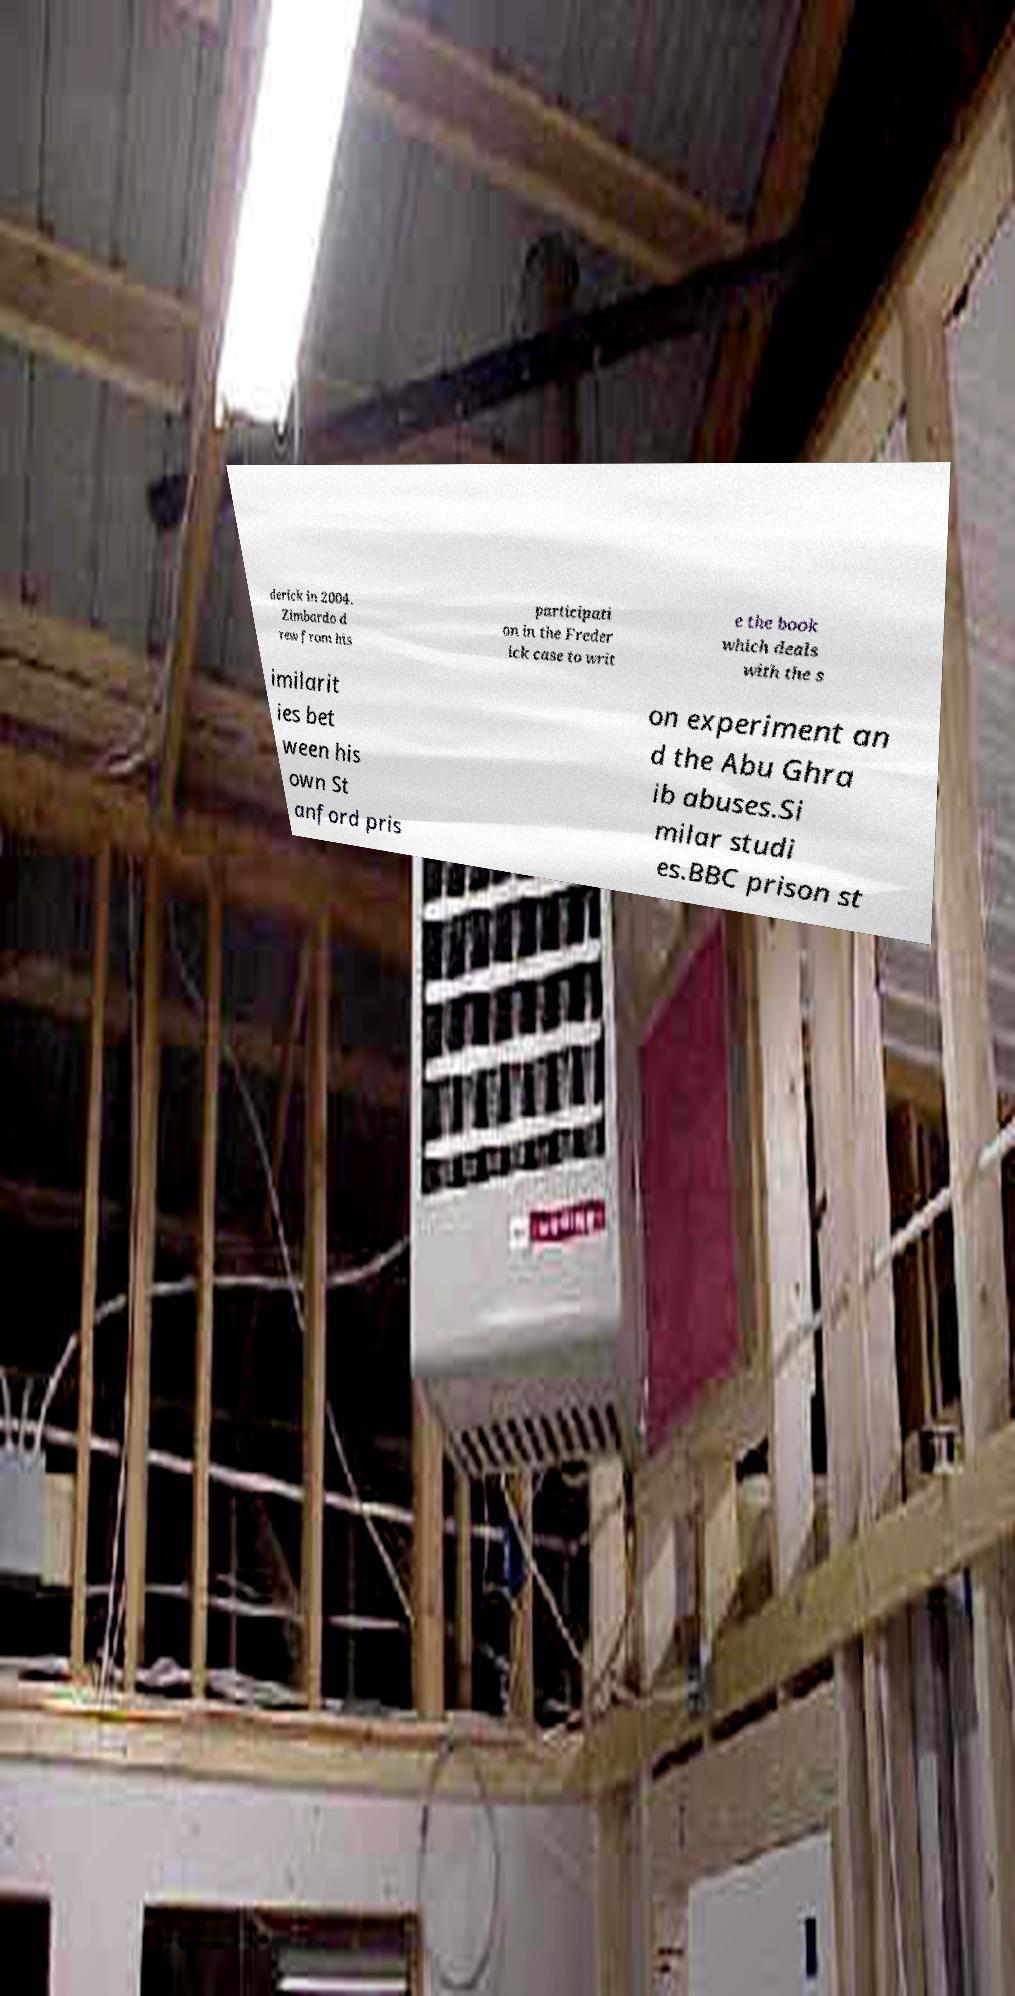Can you accurately transcribe the text from the provided image for me? derick in 2004. Zimbardo d rew from his participati on in the Freder ick case to writ e the book which deals with the s imilarit ies bet ween his own St anford pris on experiment an d the Abu Ghra ib abuses.Si milar studi es.BBC prison st 